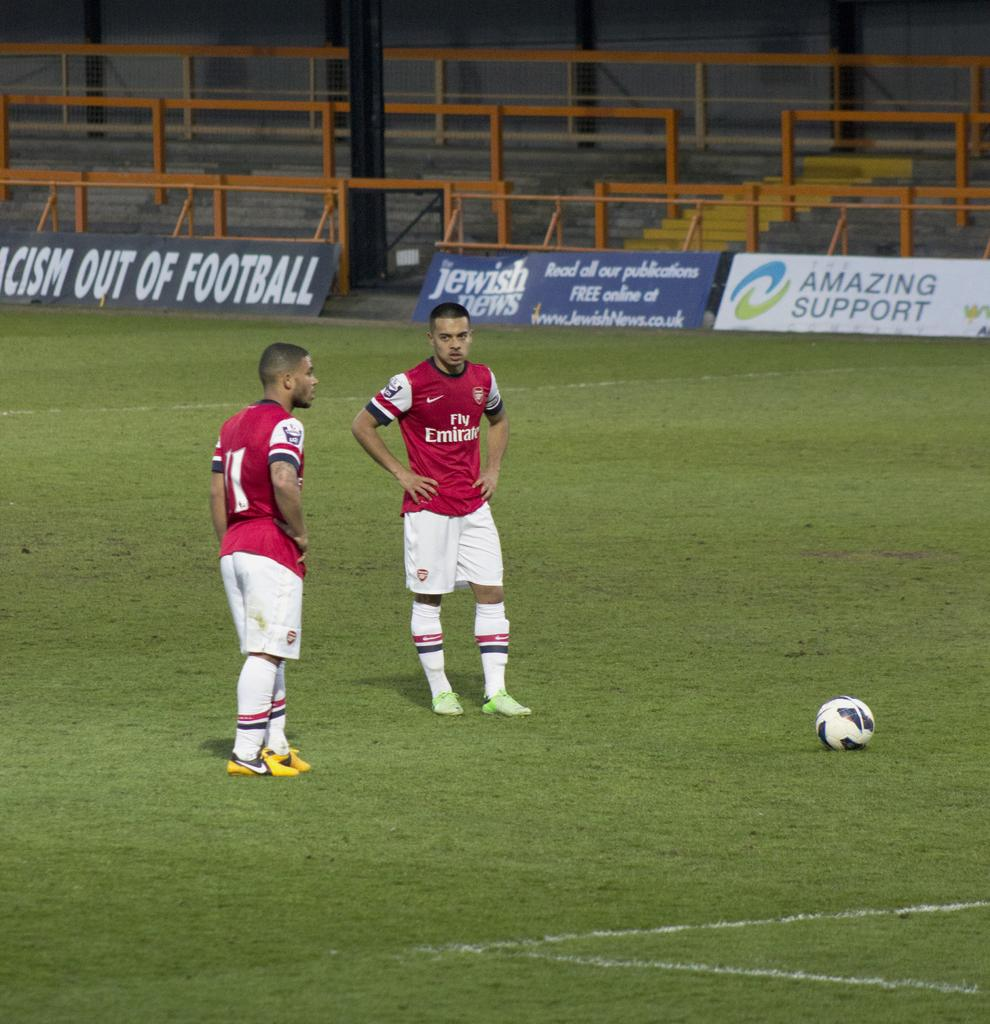<image>
Share a concise interpretation of the image provided. Two soccer players wearing Fly Emirates jerseys are standing on a soccer field. 